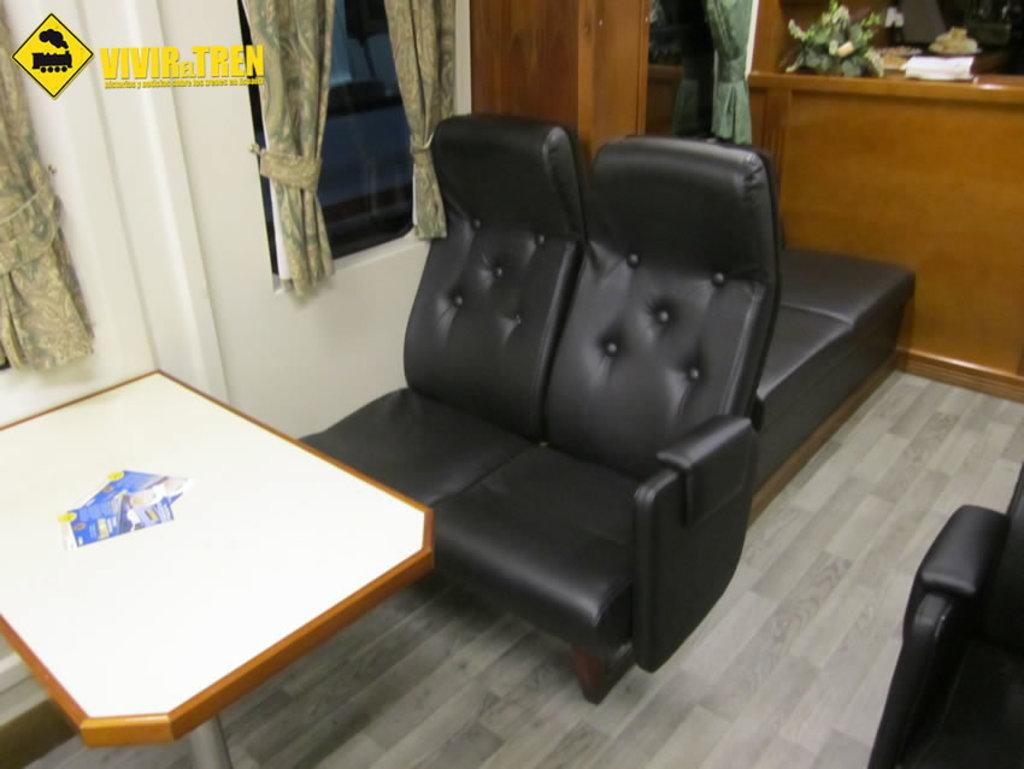What type of furniture is in the image? There is a sofa in the image. What is located in front of the sofa? There is a table in front of the sofa. What is on the table? There are papers on the table. What can be seen in the background of the image? There is a window and a wall in the background of the image. What is attached to the window? There is a curtain attached to the window. What type of agreement is being discussed in the image? There is no indication of any agreement being discussed in the image; it simply shows a sofa, table, papers, and a window with a curtain. 